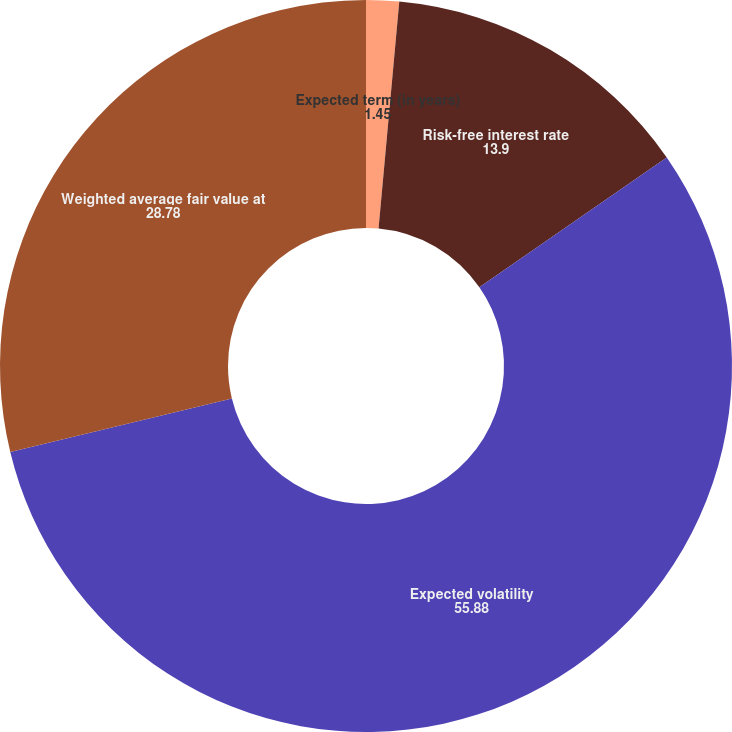Convert chart. <chart><loc_0><loc_0><loc_500><loc_500><pie_chart><fcel>Expected term (in years)<fcel>Risk-free interest rate<fcel>Expected volatility<fcel>Weighted average fair value at<nl><fcel>1.45%<fcel>13.9%<fcel>55.88%<fcel>28.78%<nl></chart> 